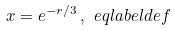<formula> <loc_0><loc_0><loc_500><loc_500>x = e ^ { - r / 3 } \, , \ e q l a b e l { d e f }</formula> 